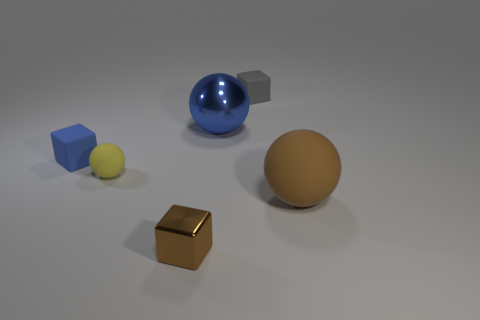The object that is in front of the gray cube and on the right side of the large blue thing is what color?
Ensure brevity in your answer.  Brown. Do the cube that is to the left of the metal block and the brown object that is left of the gray cube have the same size?
Your response must be concise. Yes. What number of large shiny things have the same color as the shiny block?
Your answer should be very brief. 0. What number of small things are brown balls or green metal objects?
Offer a terse response. 0. Is the large sphere that is in front of the blue shiny object made of the same material as the yellow thing?
Make the answer very short. Yes. There is a rubber ball that is left of the tiny gray rubber block; what is its color?
Give a very brief answer. Yellow. Are there any other blue balls of the same size as the blue sphere?
Your answer should be very brief. No. There is a brown cube that is the same size as the gray matte thing; what material is it?
Make the answer very short. Metal. Is the size of the yellow matte sphere the same as the blue shiny object to the left of the small gray matte block?
Your answer should be very brief. No. What is the material of the large thing that is on the right side of the tiny gray object?
Keep it short and to the point. Rubber. 